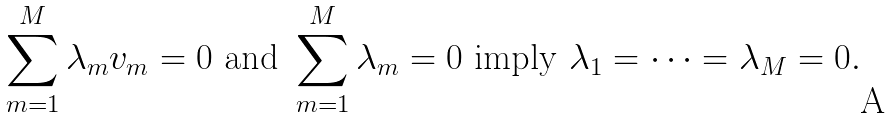Convert formula to latex. <formula><loc_0><loc_0><loc_500><loc_500>\sum _ { m = 1 } ^ { M } \lambda _ { m } v _ { m } = 0 \text { and } \sum _ { m = 1 } ^ { M } \lambda _ { m } = 0 \text { imply } \lambda _ { 1 } = \cdots = \lambda _ { M } = 0 .</formula> 